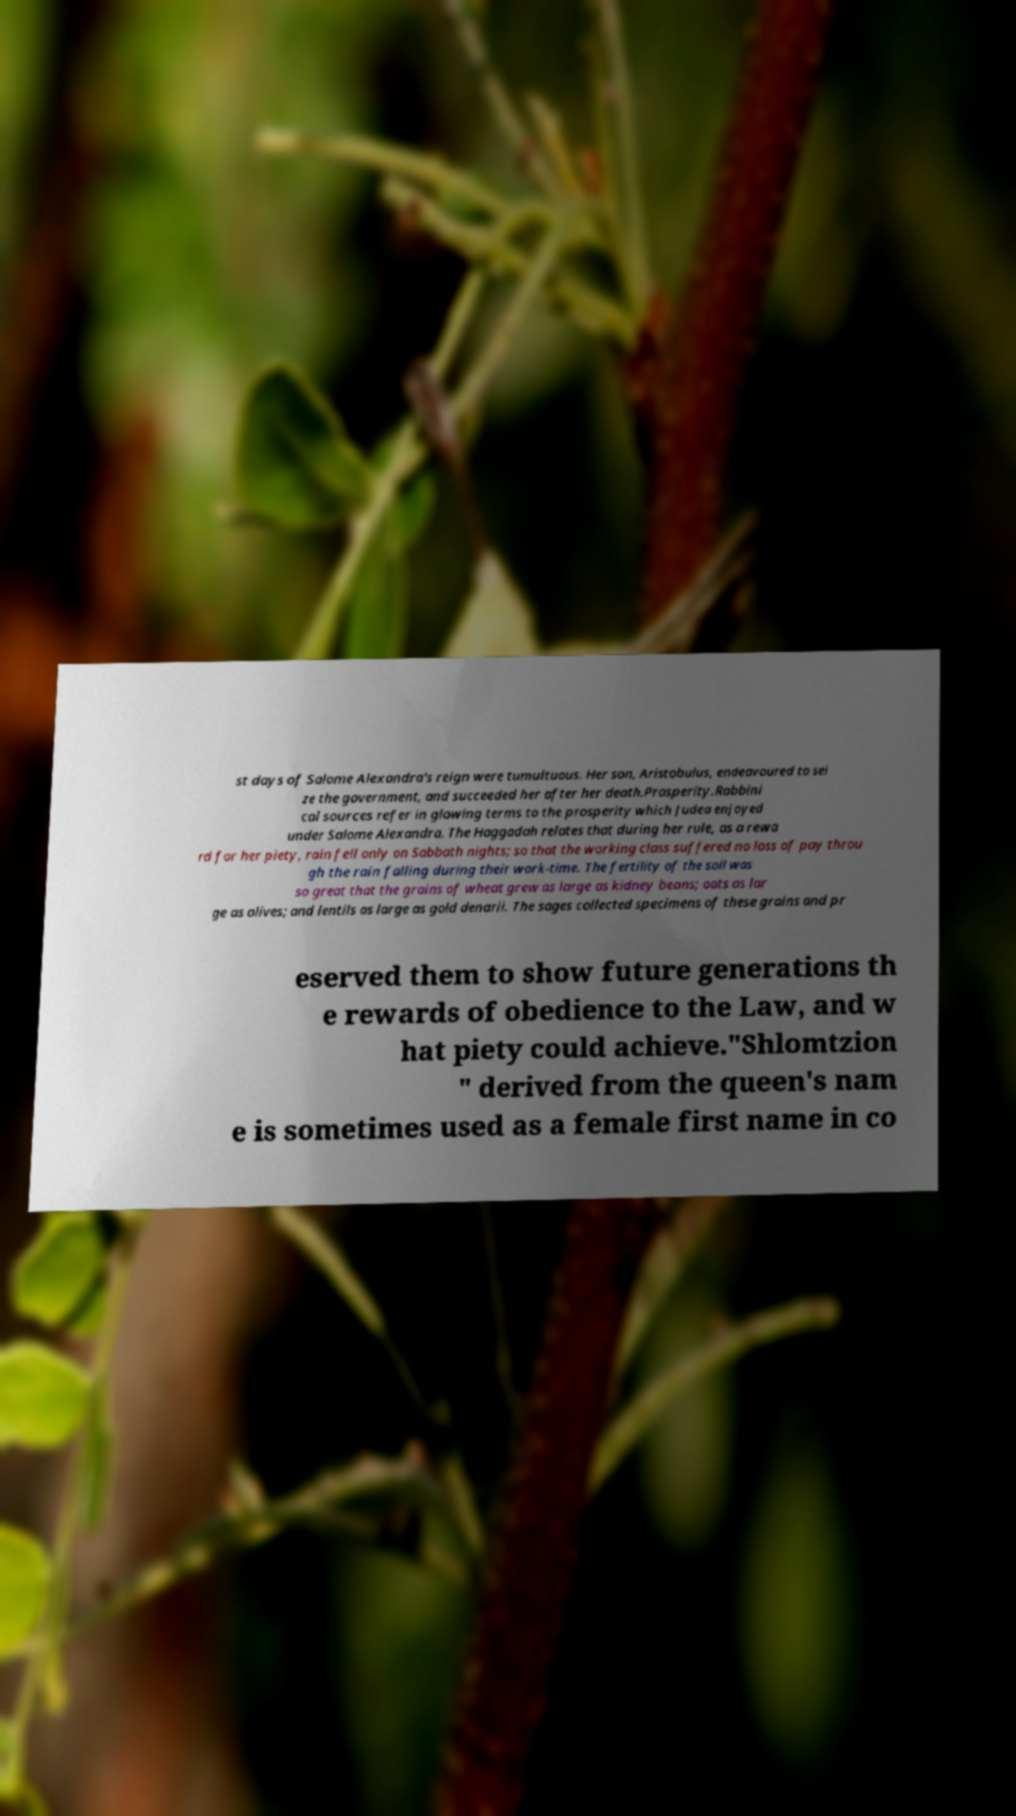Can you accurately transcribe the text from the provided image for me? st days of Salome Alexandra's reign were tumultuous. Her son, Aristobulus, endeavoured to sei ze the government, and succeeded her after her death.Prosperity.Rabbini cal sources refer in glowing terms to the prosperity which Judea enjoyed under Salome Alexandra. The Haggadah relates that during her rule, as a rewa rd for her piety, rain fell only on Sabbath nights; so that the working class suffered no loss of pay throu gh the rain falling during their work-time. The fertility of the soil was so great that the grains of wheat grew as large as kidney beans; oats as lar ge as olives; and lentils as large as gold denarii. The sages collected specimens of these grains and pr eserved them to show future generations th e rewards of obedience to the Law, and w hat piety could achieve."Shlomtzion " derived from the queen's nam e is sometimes used as a female first name in co 